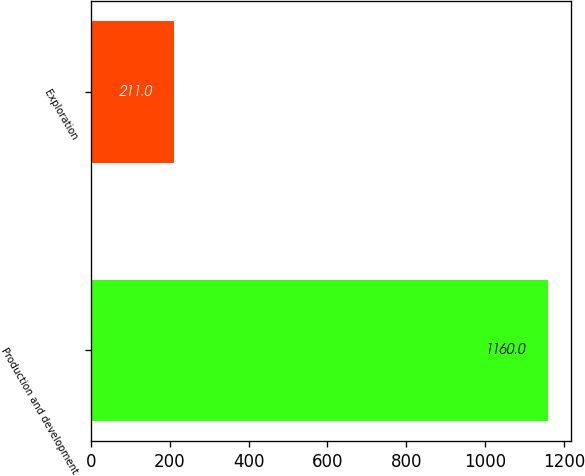<chart> <loc_0><loc_0><loc_500><loc_500><bar_chart><fcel>Production and development<fcel>Exploration<nl><fcel>1160<fcel>211<nl></chart> 